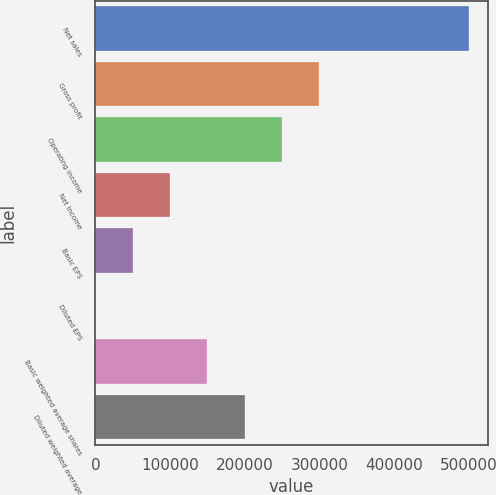Convert chart to OTSL. <chart><loc_0><loc_0><loc_500><loc_500><bar_chart><fcel>Net sales<fcel>Gross profit<fcel>Operating income<fcel>Net income<fcel>Basic EPS<fcel>Diluted EPS<fcel>Basic weighted average shares<fcel>Diluted weighted average<nl><fcel>499798<fcel>299879<fcel>249899<fcel>99960.3<fcel>49980.6<fcel>0.88<fcel>149940<fcel>199920<nl></chart> 